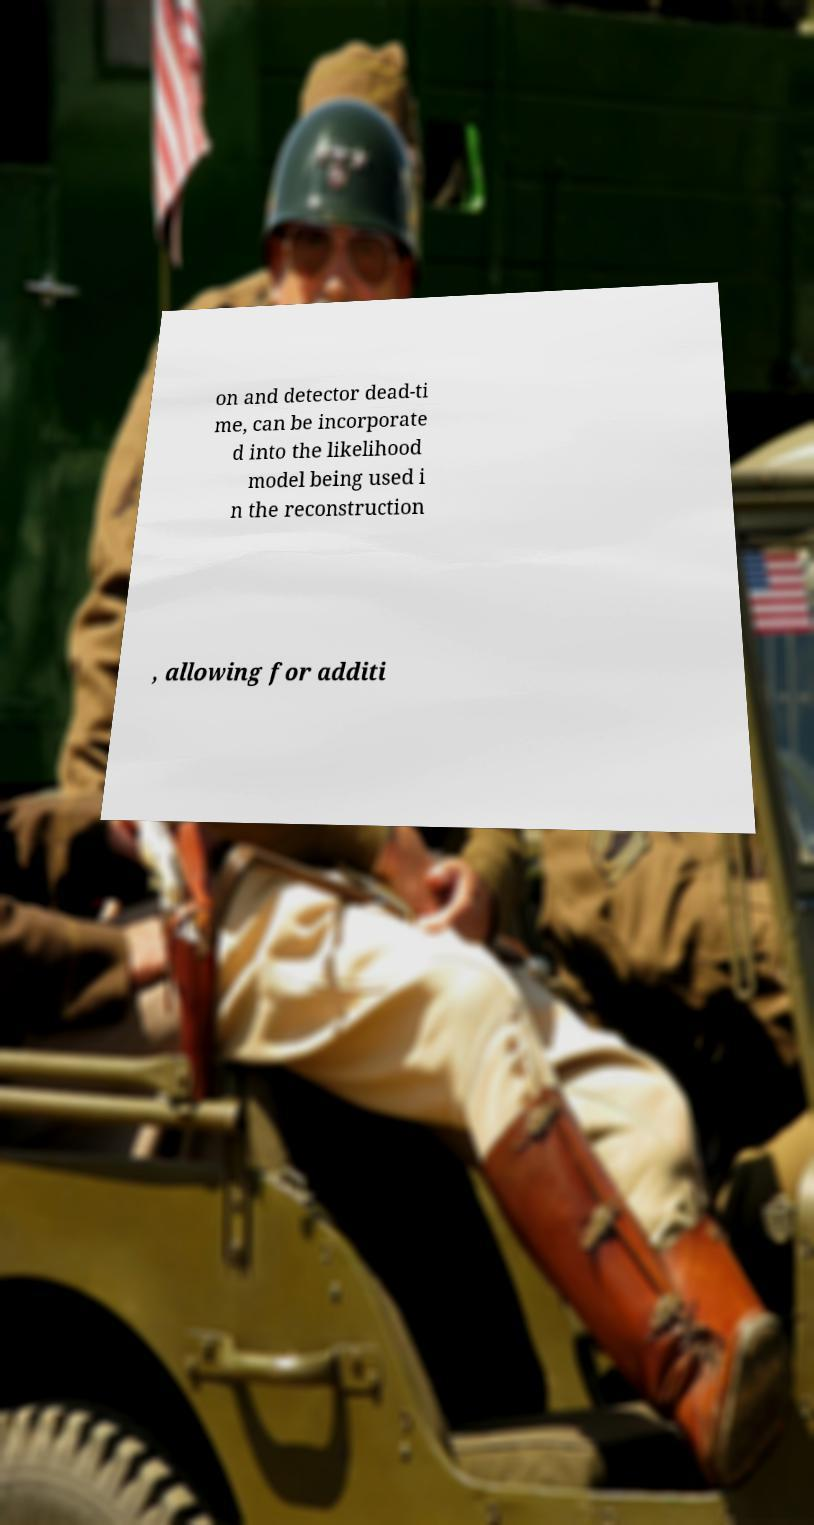I need the written content from this picture converted into text. Can you do that? on and detector dead-ti me, can be incorporate d into the likelihood model being used i n the reconstruction , allowing for additi 